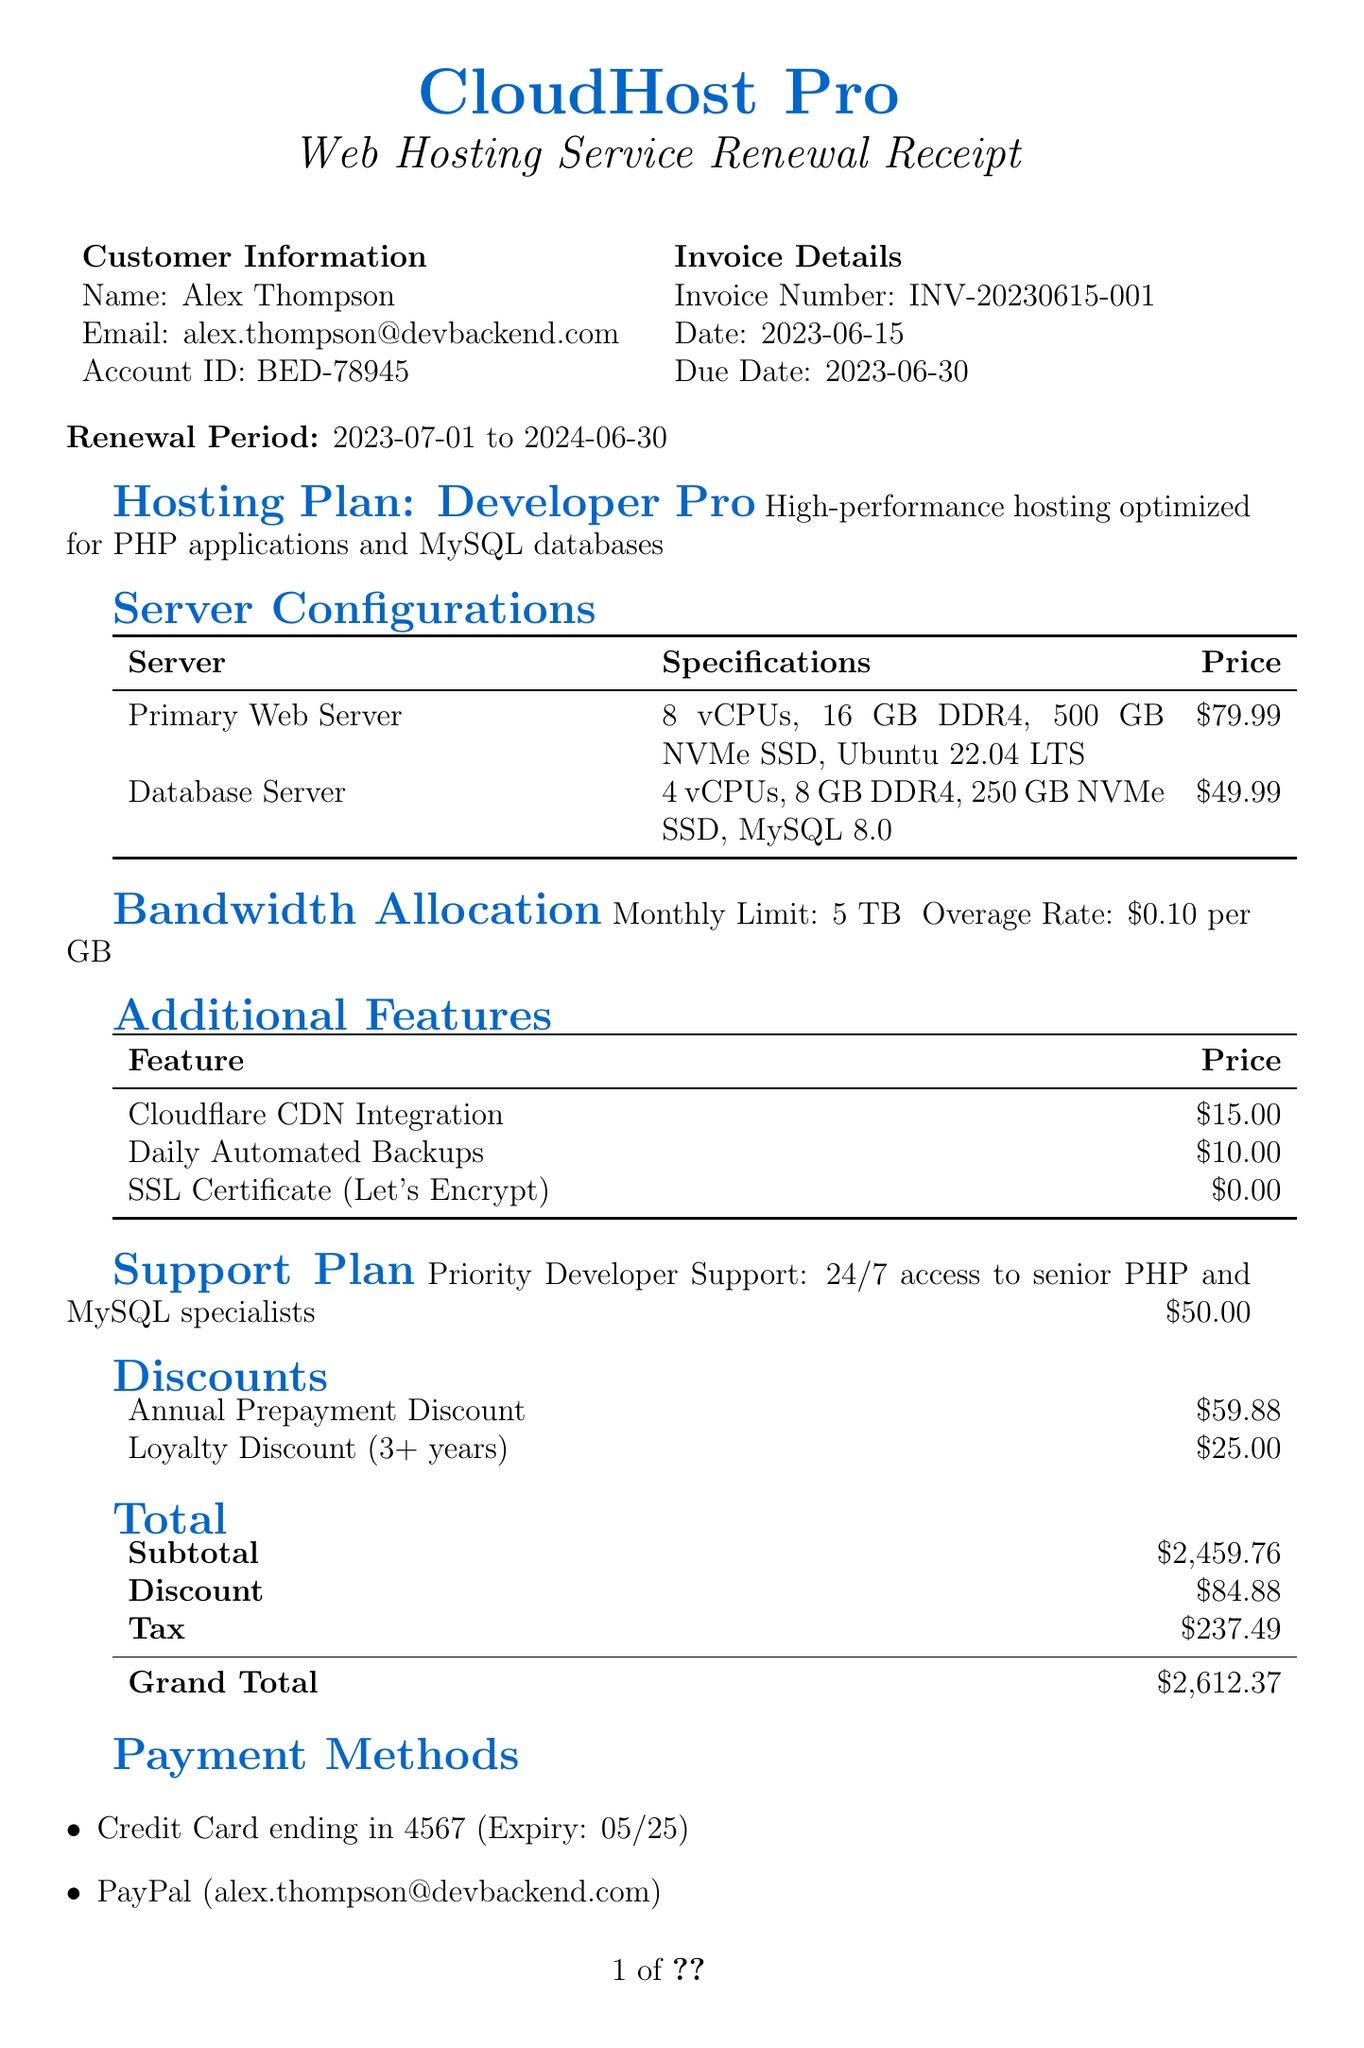What is the company name? The company name is stated at the top of the document.
Answer: CloudHost Pro What is the start date of the renewal period? The start date of the renewal period is provided under renewal period information in the document.
Answer: 2023-07-01 How many vCPUs does the Primary Web Server have? The specifications for the Primary Web Server are listed, including the number of vCPUs.
Answer: 8 vCPUs What is the price of the Database Server? The price is specified next to the Database Server under server configurations.
Answer: $49.99 What is the total amount after discounts? The total amount after discounts is found under the "Total" section, calculated from the subtotal, discounts, and tax.
Answer: $2612.37 How much is the monthly bandwidth allocation? The monthly bandwidth allocation is mentioned directly in the bandwidth section of the document.
Answer: 5 TB What discounts were applied to the invoice? The discounts are listed in the discounts section of the document.
Answer: Annual Prepayment Discount, Loyalty Discount (3+ years) What is included in the support plan? The description of the support plan details what services it includes.
Answer: 24/7 access to senior PHP and MySQL specialists How is the invoice due date formatted? The format of the due date is standard for invoices and appears near the invoice details.
Answer: 2023-06-30 